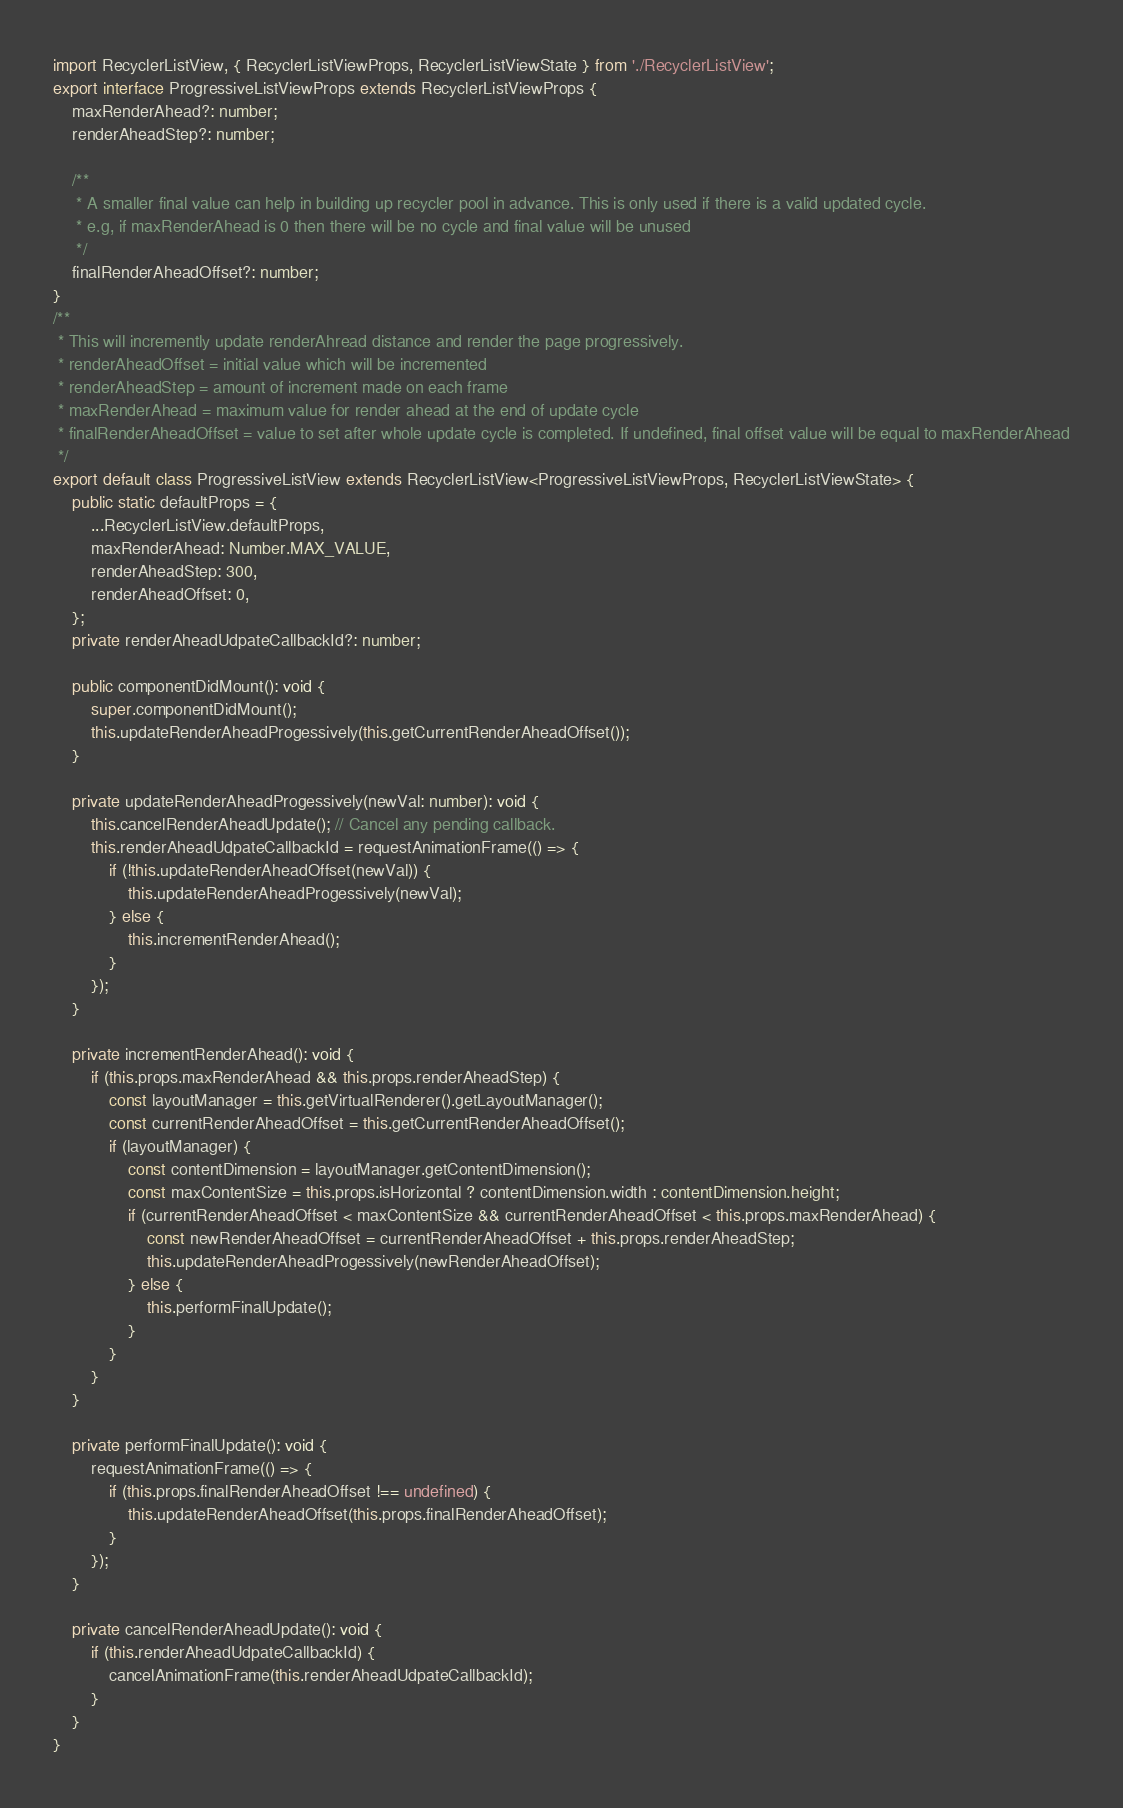Convert code to text. <code><loc_0><loc_0><loc_500><loc_500><_TypeScript_>import RecyclerListView, { RecyclerListViewProps, RecyclerListViewState } from './RecyclerListView';
export interface ProgressiveListViewProps extends RecyclerListViewProps {
    maxRenderAhead?: number;
    renderAheadStep?: number;

    /**
     * A smaller final value can help in building up recycler pool in advance. This is only used if there is a valid updated cycle.
     * e.g, if maxRenderAhead is 0 then there will be no cycle and final value will be unused
     */
    finalRenderAheadOffset?: number;
}
/**
 * This will incremently update renderAhread distance and render the page progressively.
 * renderAheadOffset = initial value which will be incremented
 * renderAheadStep = amount of increment made on each frame
 * maxRenderAhead = maximum value for render ahead at the end of update cycle
 * finalRenderAheadOffset = value to set after whole update cycle is completed. If undefined, final offset value will be equal to maxRenderAhead
 */
export default class ProgressiveListView extends RecyclerListView<ProgressiveListViewProps, RecyclerListViewState> {
    public static defaultProps = {
        ...RecyclerListView.defaultProps,
        maxRenderAhead: Number.MAX_VALUE,
        renderAheadStep: 300,
        renderAheadOffset: 0,
    };
    private renderAheadUdpateCallbackId?: number;

    public componentDidMount(): void {
        super.componentDidMount();
        this.updateRenderAheadProgessively(this.getCurrentRenderAheadOffset());
    }

    private updateRenderAheadProgessively(newVal: number): void {
        this.cancelRenderAheadUpdate(); // Cancel any pending callback.
        this.renderAheadUdpateCallbackId = requestAnimationFrame(() => {
            if (!this.updateRenderAheadOffset(newVal)) {
                this.updateRenderAheadProgessively(newVal);
            } else {
                this.incrementRenderAhead();
            }
        });
    }

    private incrementRenderAhead(): void {
        if (this.props.maxRenderAhead && this.props.renderAheadStep) {
            const layoutManager = this.getVirtualRenderer().getLayoutManager();
            const currentRenderAheadOffset = this.getCurrentRenderAheadOffset();
            if (layoutManager) {
                const contentDimension = layoutManager.getContentDimension();
                const maxContentSize = this.props.isHorizontal ? contentDimension.width : contentDimension.height;
                if (currentRenderAheadOffset < maxContentSize && currentRenderAheadOffset < this.props.maxRenderAhead) {
                    const newRenderAheadOffset = currentRenderAheadOffset + this.props.renderAheadStep;
                    this.updateRenderAheadProgessively(newRenderAheadOffset);
                } else {
                    this.performFinalUpdate();
                }
            }
        }
    }

    private performFinalUpdate(): void {
        requestAnimationFrame(() => {
            if (this.props.finalRenderAheadOffset !== undefined) {
                this.updateRenderAheadOffset(this.props.finalRenderAheadOffset);
            }
        });
    }

    private cancelRenderAheadUpdate(): void {
        if (this.renderAheadUdpateCallbackId) {
            cancelAnimationFrame(this.renderAheadUdpateCallbackId);
        }
    }
}
</code> 